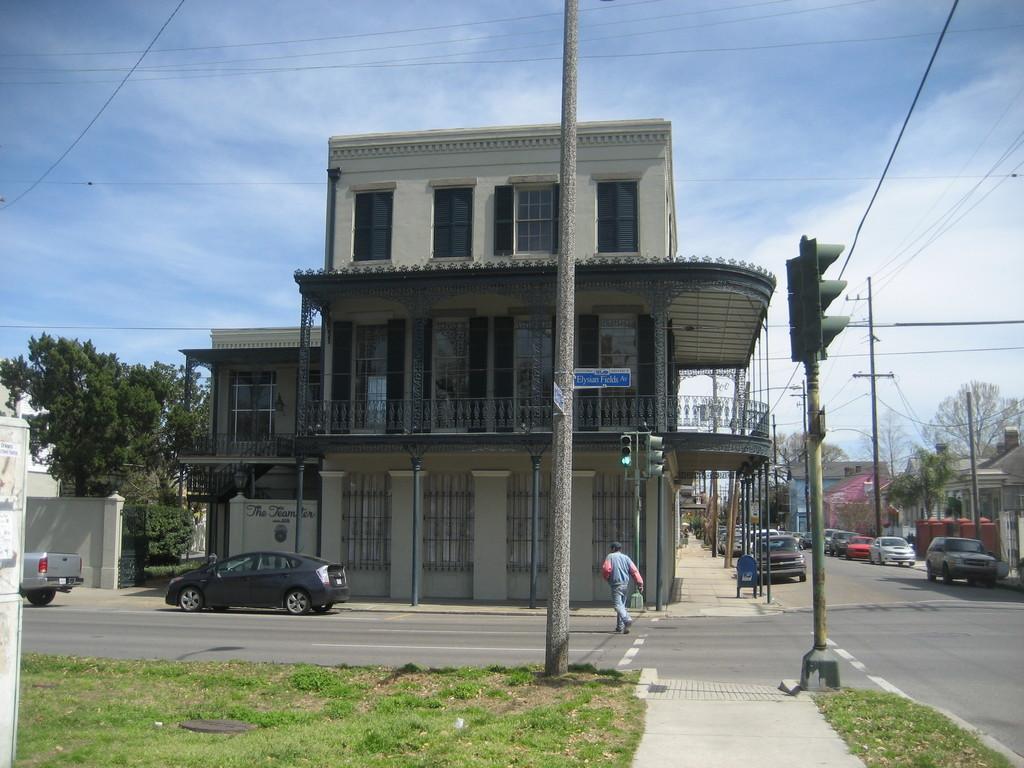Could you give a brief overview of what you see in this image? On the left side, there is a person walking on the road, on which there are two vehicles. Beside this road, there are a pole and grass on the ground. On the right side, there is a road. Beside this road, there are a pole and grass on the ground. Beside this grass, there is a footpath. In the background, there is a person walking on the road, there are vehicles parked aside on the road, there are buildings and trees on the ground and there are clouds in the blue sky. 